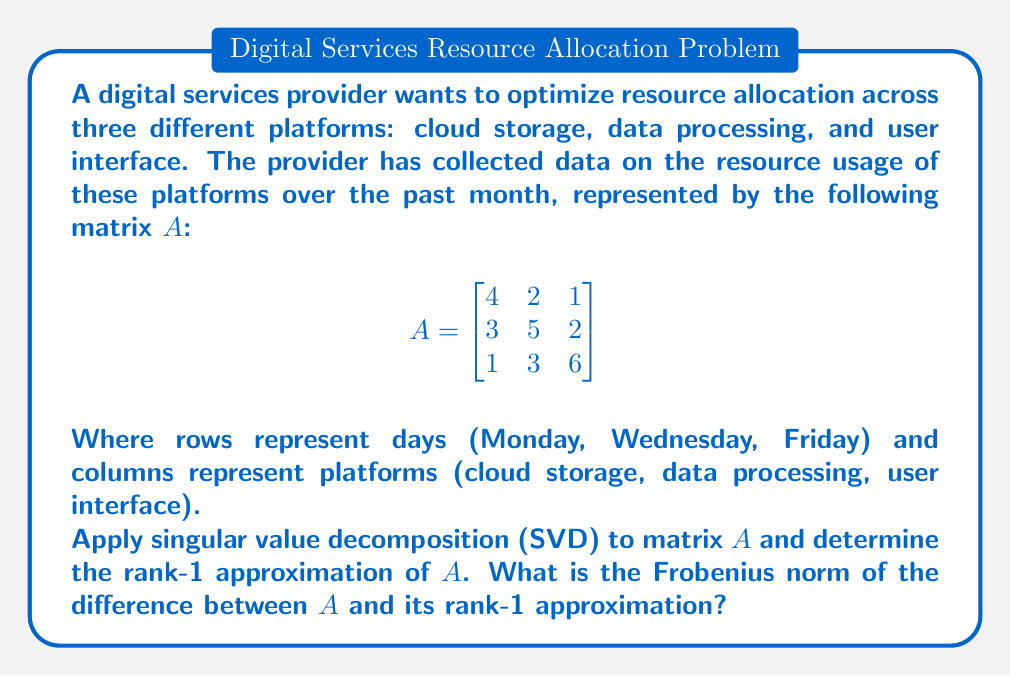Can you answer this question? To solve this problem, we'll follow these steps:

1) First, we need to compute the Singular Value Decomposition (SVD) of matrix $A$. The SVD of $A$ is given by $A = U\Sigma V^T$, where $U$ and $V$ are orthogonal matrices and $\Sigma$ is a diagonal matrix containing the singular values.

2) We can use a computer algebra system to calculate the SVD. The result is:

   $U = \begin{bmatrix}
   -0.3984 & -0.6708 & 0.6245 \\
   -0.5775 & 0.7161 & 0.3912 \\
   -0.7127 & -0.1913 & -0.6754
   \end{bmatrix}$

   $\Sigma = \begin{bmatrix}
   9.5214 & 0 & 0 \\
   0 & 3.6956 & 0 \\
   0 & 0 & 0.8637
   \end{bmatrix}$

   $V^T = \begin{bmatrix}
   -0.4288 & -0.6351 & -0.6414 \\
   -0.5663 & 0.7717 & -0.2879 \\
   -0.7040 & -0.0366 & 0.7093
   \end{bmatrix}$

3) The rank-1 approximation of $A$ is given by the first term of the SVD expansion:

   $A_1 = \sigma_1 u_1 v_1^T$

   Where $\sigma_1$ is the largest singular value, $u_1$ is the first column of $U$, and $v_1$ is the first column of $V$.

4) We can calculate $A_1$:

   $A_1 = 9.5214 \cdot \begin{bmatrix}-0.3984 \\ -0.5775 \\ -0.7127\end{bmatrix} \cdot \begin{bmatrix}-0.4288 & -0.6351 & -0.6414\end{bmatrix}$

   $A_1 = \begin{bmatrix}
   1.6266 & 2.4090 & 2.4324 \\
   2.3580 & 3.4923 & 3.5262 \\
   2.9100 & 4.3109 & 4.3530
   \end{bmatrix}$

5) To find the Frobenius norm of the difference between $A$ and $A_1$, we first calculate $A - A_1$:

   $A - A_1 = \begin{bmatrix}
   2.3734 & -0.4090 & -1.4324 \\
   0.6420 & 1.5077 & -1.5262 \\
   -1.9100 & -1.3109 & 1.6470
   \end{bmatrix}$

6) The Frobenius norm is the square root of the sum of the squares of all elements:

   $\|A - A_1\|_F = \sqrt{(2.3734)^2 + (-0.4090)^2 + ... + (1.6470)^2}$

7) Calculating this:

   $\|A - A_1\|_F = \sqrt{19.0817} \approx 4.3682$
Answer: $4.3682$ 